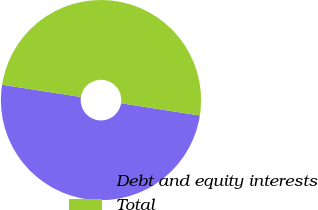<chart> <loc_0><loc_0><loc_500><loc_500><pie_chart><fcel>Debt and equity interests<fcel>Total<nl><fcel>50.0%<fcel>50.0%<nl></chart> 